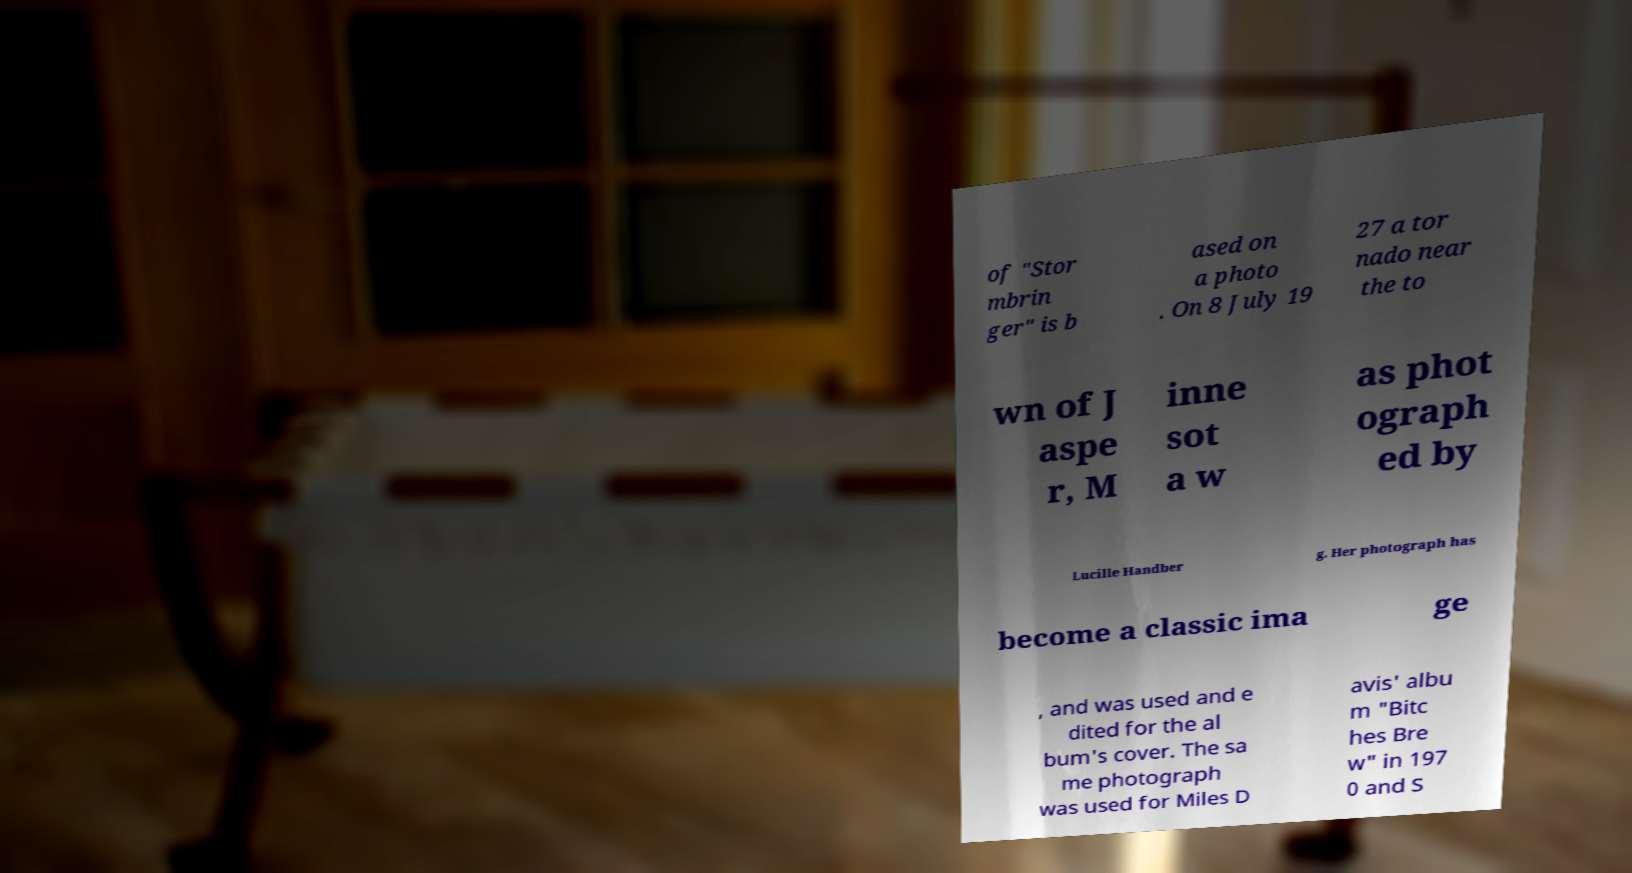Can you read and provide the text displayed in the image?This photo seems to have some interesting text. Can you extract and type it out for me? of "Stor mbrin ger" is b ased on a photo . On 8 July 19 27 a tor nado near the to wn of J aspe r, M inne sot a w as phot ograph ed by Lucille Handber g. Her photograph has become a classic ima ge , and was used and e dited for the al bum's cover. The sa me photograph was used for Miles D avis' albu m "Bitc hes Bre w" in 197 0 and S 